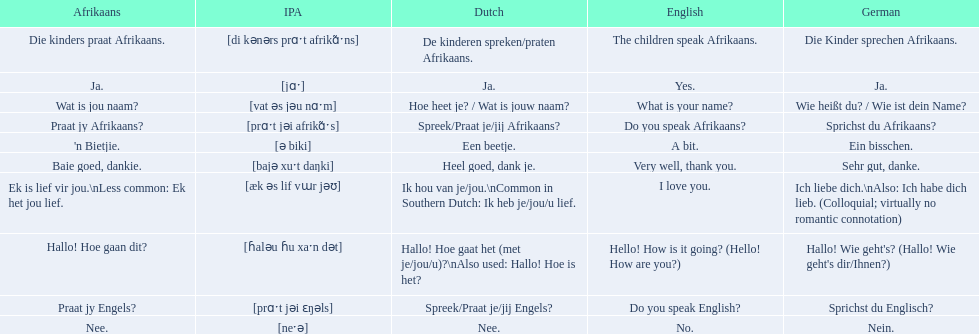Can you parse all the data within this table? {'header': ['Afrikaans', 'IPA', 'Dutch', 'English', 'German'], 'rows': [['Die kinders praat Afrikaans.', '[di kənərs prɑˑt afrikɑ̃ˑns]', 'De kinderen spreken/praten Afrikaans.', 'The children speak Afrikaans.', 'Die Kinder sprechen Afrikaans.'], ['Ja.', '[jɑˑ]', 'Ja.', 'Yes.', 'Ja.'], ['Wat is jou naam?', '[vat əs jəu nɑˑm]', 'Hoe heet je? / Wat is jouw naam?', 'What is your name?', 'Wie heißt du? / Wie ist dein Name?'], ['Praat jy Afrikaans?', '[prɑˑt jəi afrikɑ̃ˑs]', 'Spreek/Praat je/jij Afrikaans?', 'Do you speak Afrikaans?', 'Sprichst du Afrikaans?'], ["'n Bietjie.", '[ə biki]', 'Een beetje.', 'A bit.', 'Ein bisschen.'], ['Baie goed, dankie.', '[bajə xuˑt daŋki]', 'Heel goed, dank je.', 'Very well, thank you.', 'Sehr gut, danke.'], ['Ek is lief vir jou.\\nLess common: Ek het jou lief.', '[æk əs lif vɯr jəʊ]', 'Ik hou van je/jou.\\nCommon in Southern Dutch: Ik heb je/jou/u lief.', 'I love you.', 'Ich liebe dich.\\nAlso: Ich habe dich lieb. (Colloquial; virtually no romantic connotation)'], ['Hallo! Hoe gaan dit?', '[ɦaləu ɦu xaˑn dət]', 'Hallo! Hoe gaat het (met je/jou/u)?\\nAlso used: Hallo! Hoe is het?', 'Hello! How is it going? (Hello! How are you?)', "Hallo! Wie geht's? (Hallo! Wie geht's dir/Ihnen?)"], ['Praat jy Engels?', '[prɑˑt jəi ɛŋəls]', 'Spreek/Praat je/jij Engels?', 'Do you speak English?', 'Sprichst du Englisch?'], ['Nee.', '[neˑə]', 'Nee.', 'No.', 'Nein.']]} What are all of the afrikaans phrases shown in the table? Hallo! Hoe gaan dit?, Baie goed, dankie., Praat jy Afrikaans?, Praat jy Engels?, Ja., Nee., 'n Bietjie., Wat is jou naam?, Die kinders praat Afrikaans., Ek is lief vir jou.\nLess common: Ek het jou lief. Of those, which translates into english as do you speak afrikaans?? Praat jy Afrikaans?. 